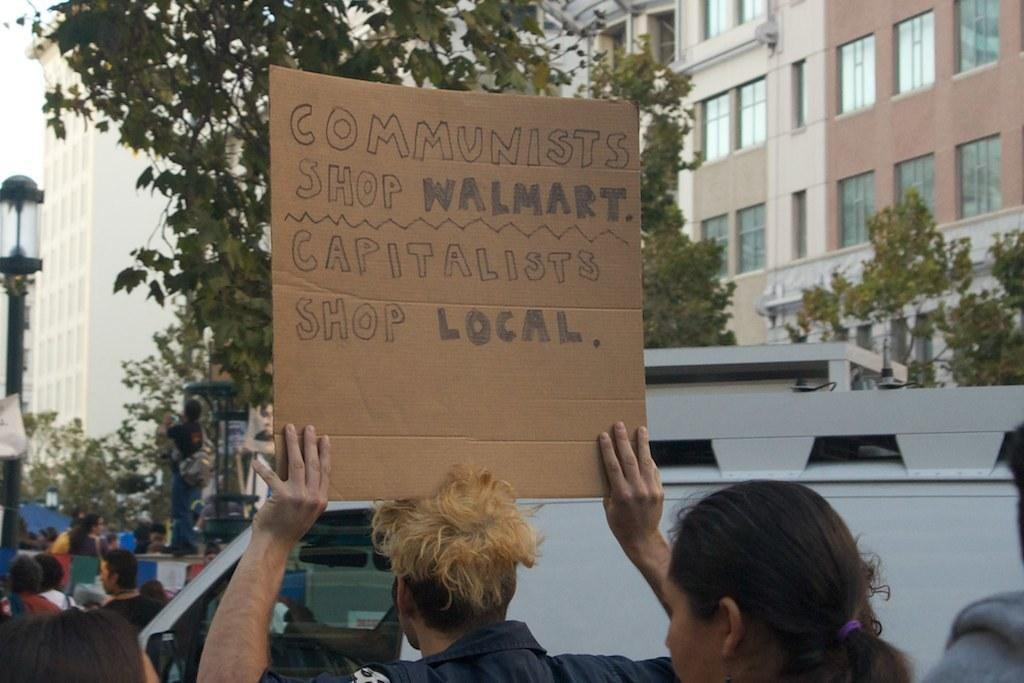How many people are visible in the image? There are people in the image, but the exact number cannot be determined from the provided facts. What can be seen on the road in the image? There are vehicles on the road in the image. What are some people holding in the image? Some people are holding a board with text in the image. What can be seen in the background of the image? There are buildings, trees, and poles in the background of the image. What type of bird is sitting on the father's shoulder in the image? There is no father or bird present in the image. How many frogs can be seen hopping around the people in the image? There are no frogs visible in the image. 